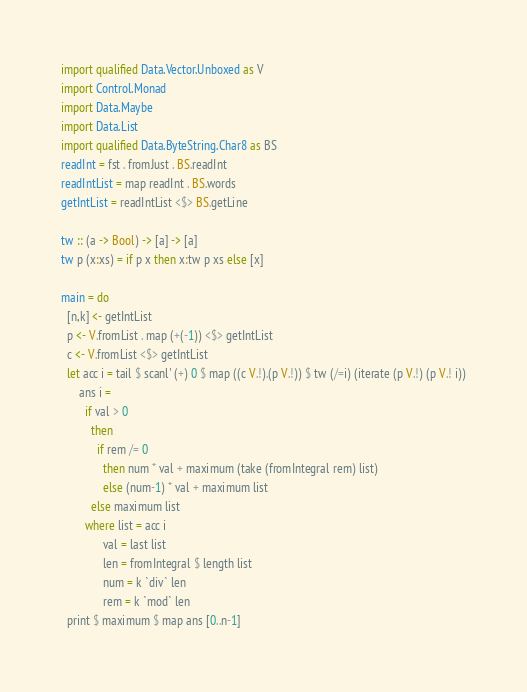Convert code to text. <code><loc_0><loc_0><loc_500><loc_500><_Haskell_>import qualified Data.Vector.Unboxed as V
import Control.Monad
import Data.Maybe
import Data.List
import qualified Data.ByteString.Char8 as BS
readInt = fst . fromJust . BS.readInt
readIntList = map readInt . BS.words
getIntList = readIntList <$> BS.getLine

tw :: (a -> Bool) -> [a] -> [a]
tw p (x:xs) = if p x then x:tw p xs else [x]

main = do
  [n,k] <- getIntList
  p <- V.fromList . map (+(-1)) <$> getIntList
  c <- V.fromList <$> getIntList
  let acc i = tail $ scanl' (+) 0 $ map ((c V.!).(p V.!)) $ tw (/=i) (iterate (p V.!) (p V.! i))
      ans i = 
        if val > 0
          then
            if rem /= 0
              then num * val + maximum (take (fromIntegral rem) list)
              else (num-1) * val + maximum list
          else maximum list
        where list = acc i
              val = last list
              len = fromIntegral $ length list
              num = k `div` len
              rem = k `mod` len
  print $ maximum $ map ans [0..n-1]
</code> 